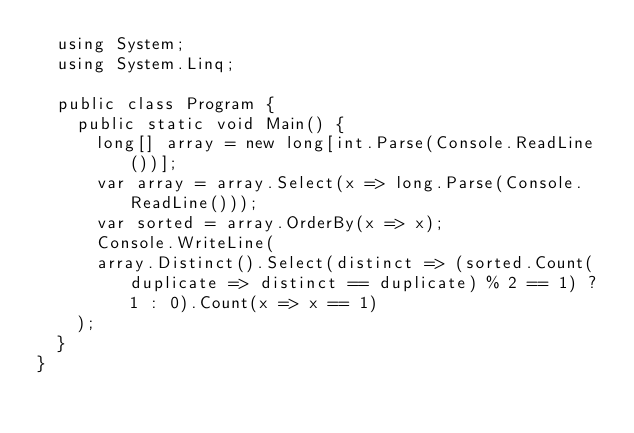Convert code to text. <code><loc_0><loc_0><loc_500><loc_500><_C#_>  using System;
  using System.Linq;

  public class Program {
    public static void Main() {
      long[] array = new long[int.Parse(Console.ReadLine())];
      var array = array.Select(x => long.Parse(Console.ReadLine()));
      var sorted = array.OrderBy(x => x);
      Console.WriteLine(
      array.Distinct().Select(distinct => (sorted.Count(duplicate => distinct == duplicate) % 2 == 1) ? 1 : 0).Count(x => x == 1)
    );
  }
}</code> 